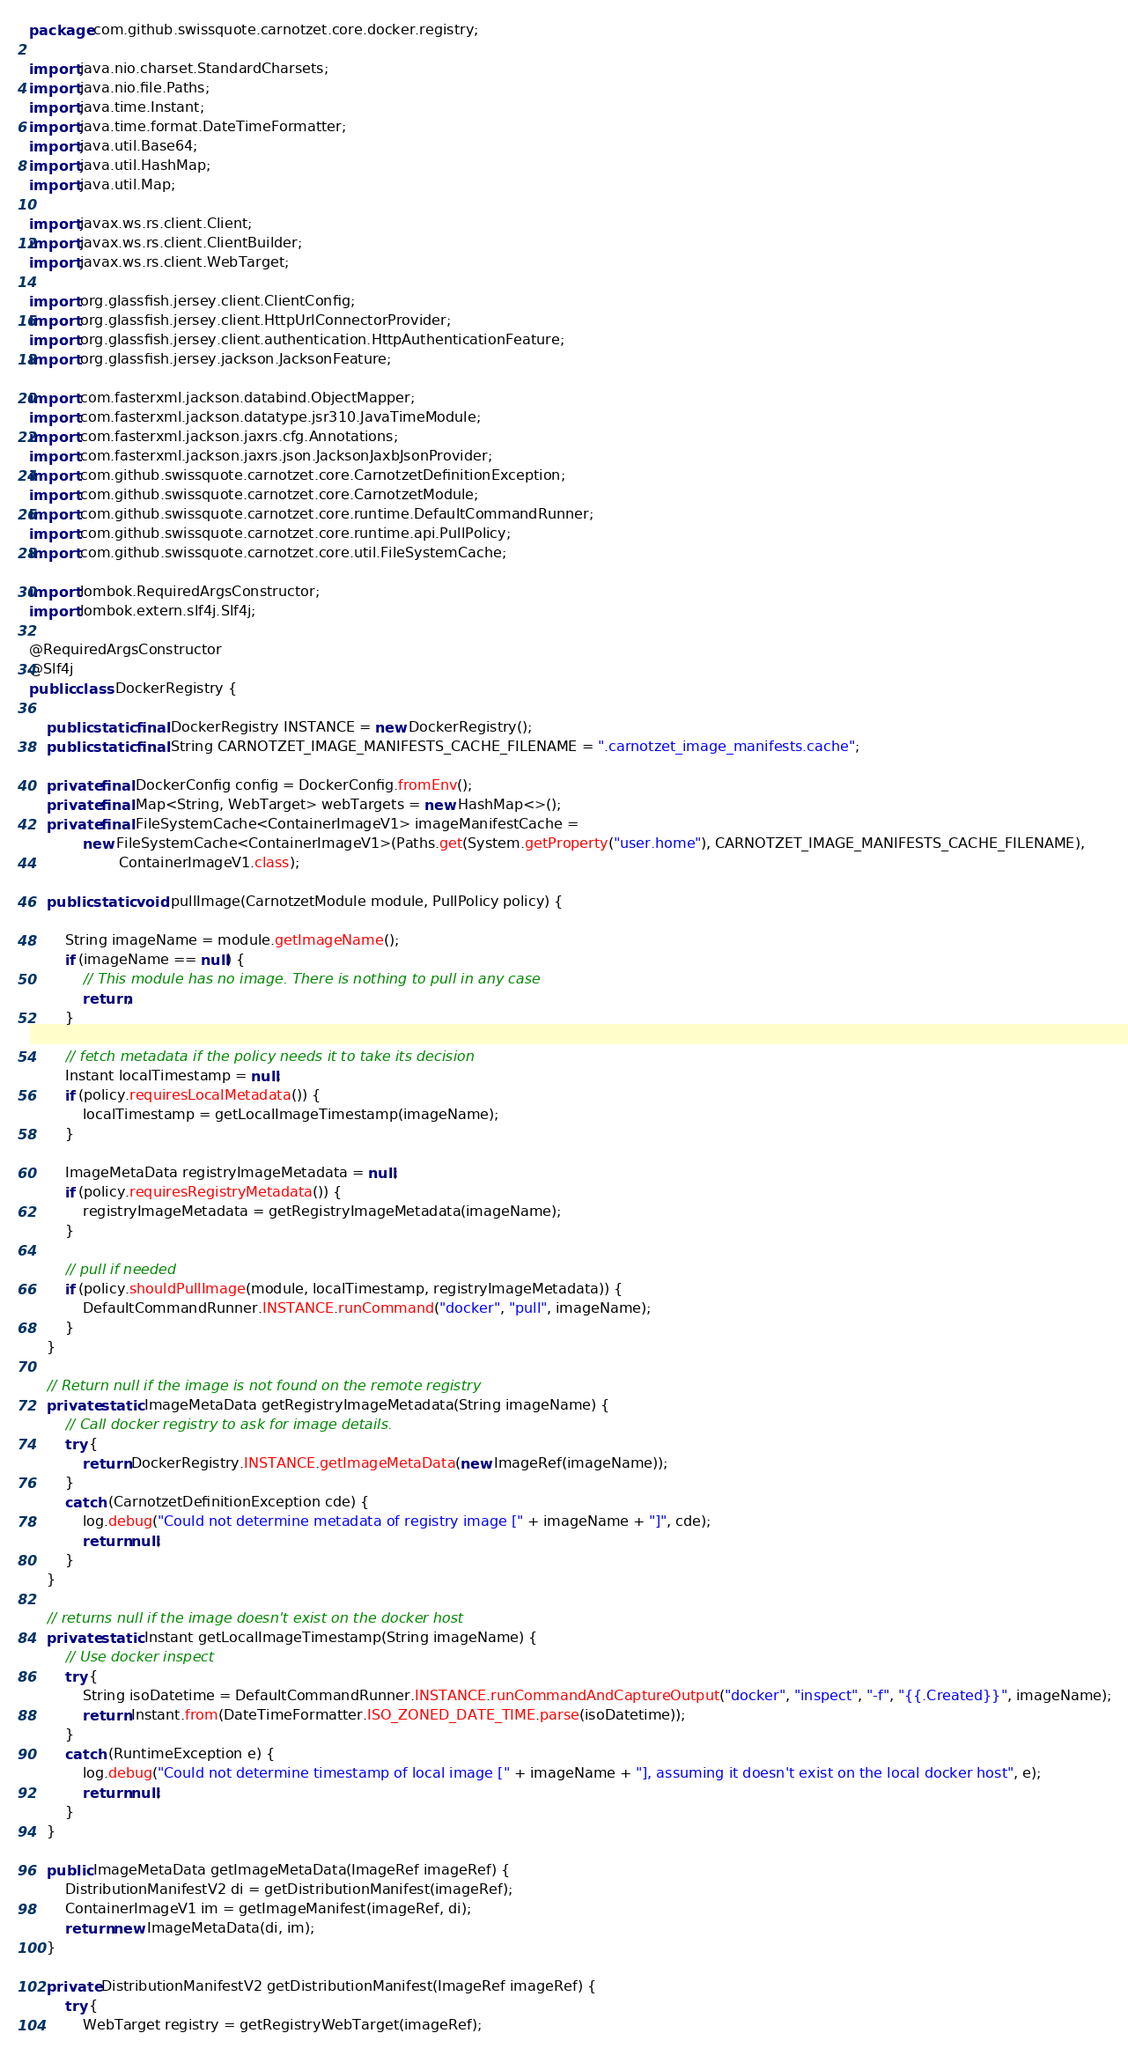Convert code to text. <code><loc_0><loc_0><loc_500><loc_500><_Java_>package com.github.swissquote.carnotzet.core.docker.registry;

import java.nio.charset.StandardCharsets;
import java.nio.file.Paths;
import java.time.Instant;
import java.time.format.DateTimeFormatter;
import java.util.Base64;
import java.util.HashMap;
import java.util.Map;

import javax.ws.rs.client.Client;
import javax.ws.rs.client.ClientBuilder;
import javax.ws.rs.client.WebTarget;

import org.glassfish.jersey.client.ClientConfig;
import org.glassfish.jersey.client.HttpUrlConnectorProvider;
import org.glassfish.jersey.client.authentication.HttpAuthenticationFeature;
import org.glassfish.jersey.jackson.JacksonFeature;

import com.fasterxml.jackson.databind.ObjectMapper;
import com.fasterxml.jackson.datatype.jsr310.JavaTimeModule;
import com.fasterxml.jackson.jaxrs.cfg.Annotations;
import com.fasterxml.jackson.jaxrs.json.JacksonJaxbJsonProvider;
import com.github.swissquote.carnotzet.core.CarnotzetDefinitionException;
import com.github.swissquote.carnotzet.core.CarnotzetModule;
import com.github.swissquote.carnotzet.core.runtime.DefaultCommandRunner;
import com.github.swissquote.carnotzet.core.runtime.api.PullPolicy;
import com.github.swissquote.carnotzet.core.util.FileSystemCache;

import lombok.RequiredArgsConstructor;
import lombok.extern.slf4j.Slf4j;

@RequiredArgsConstructor
@Slf4j
public class DockerRegistry {

	public static final DockerRegistry INSTANCE = new DockerRegistry();
	public static final String CARNOTZET_IMAGE_MANIFESTS_CACHE_FILENAME = ".carnotzet_image_manifests.cache";

	private final DockerConfig config = DockerConfig.fromEnv();
	private final Map<String, WebTarget> webTargets = new HashMap<>();
	private final FileSystemCache<ContainerImageV1> imageManifestCache =
			new FileSystemCache<ContainerImageV1>(Paths.get(System.getProperty("user.home"), CARNOTZET_IMAGE_MANIFESTS_CACHE_FILENAME),
					ContainerImageV1.class);

	public static void pullImage(CarnotzetModule module, PullPolicy policy) {

		String imageName = module.getImageName();
		if (imageName == null) {
			// This module has no image. There is nothing to pull in any case
			return;
		}

		// fetch metadata if the policy needs it to take its decision
		Instant localTimestamp = null;
		if (policy.requiresLocalMetadata()) {
			localTimestamp = getLocalImageTimestamp(imageName);
		}

		ImageMetaData registryImageMetadata = null;
		if (policy.requiresRegistryMetadata()) {
			registryImageMetadata = getRegistryImageMetadata(imageName);
		}

		// pull if needed
		if (policy.shouldPullImage(module, localTimestamp, registryImageMetadata)) {
			DefaultCommandRunner.INSTANCE.runCommand("docker", "pull", imageName);
		}
	}

	// Return null if the image is not found on the remote registry
	private static ImageMetaData getRegistryImageMetadata(String imageName) {
		// Call docker registry to ask for image details.
		try {
			return DockerRegistry.INSTANCE.getImageMetaData(new ImageRef(imageName));
		}
		catch (CarnotzetDefinitionException cde) {
			log.debug("Could not determine metadata of registry image [" + imageName + "]", cde);
			return null;
		}
	}

	// returns null if the image doesn't exist on the docker host
	private static Instant getLocalImageTimestamp(String imageName) {
		// Use docker inspect
		try {
			String isoDatetime = DefaultCommandRunner.INSTANCE.runCommandAndCaptureOutput("docker", "inspect", "-f", "{{.Created}}", imageName);
			return Instant.from(DateTimeFormatter.ISO_ZONED_DATE_TIME.parse(isoDatetime));
		}
		catch (RuntimeException e) {
			log.debug("Could not determine timestamp of local image [" + imageName + "], assuming it doesn't exist on the local docker host", e);
			return null;
		}
	}

	public ImageMetaData getImageMetaData(ImageRef imageRef) {
		DistributionManifestV2 di = getDistributionManifest(imageRef);
		ContainerImageV1 im = getImageManifest(imageRef, di);
		return new ImageMetaData(di, im);
	}

	private DistributionManifestV2 getDistributionManifest(ImageRef imageRef) {
		try {
			WebTarget registry = getRegistryWebTarget(imageRef);
</code> 